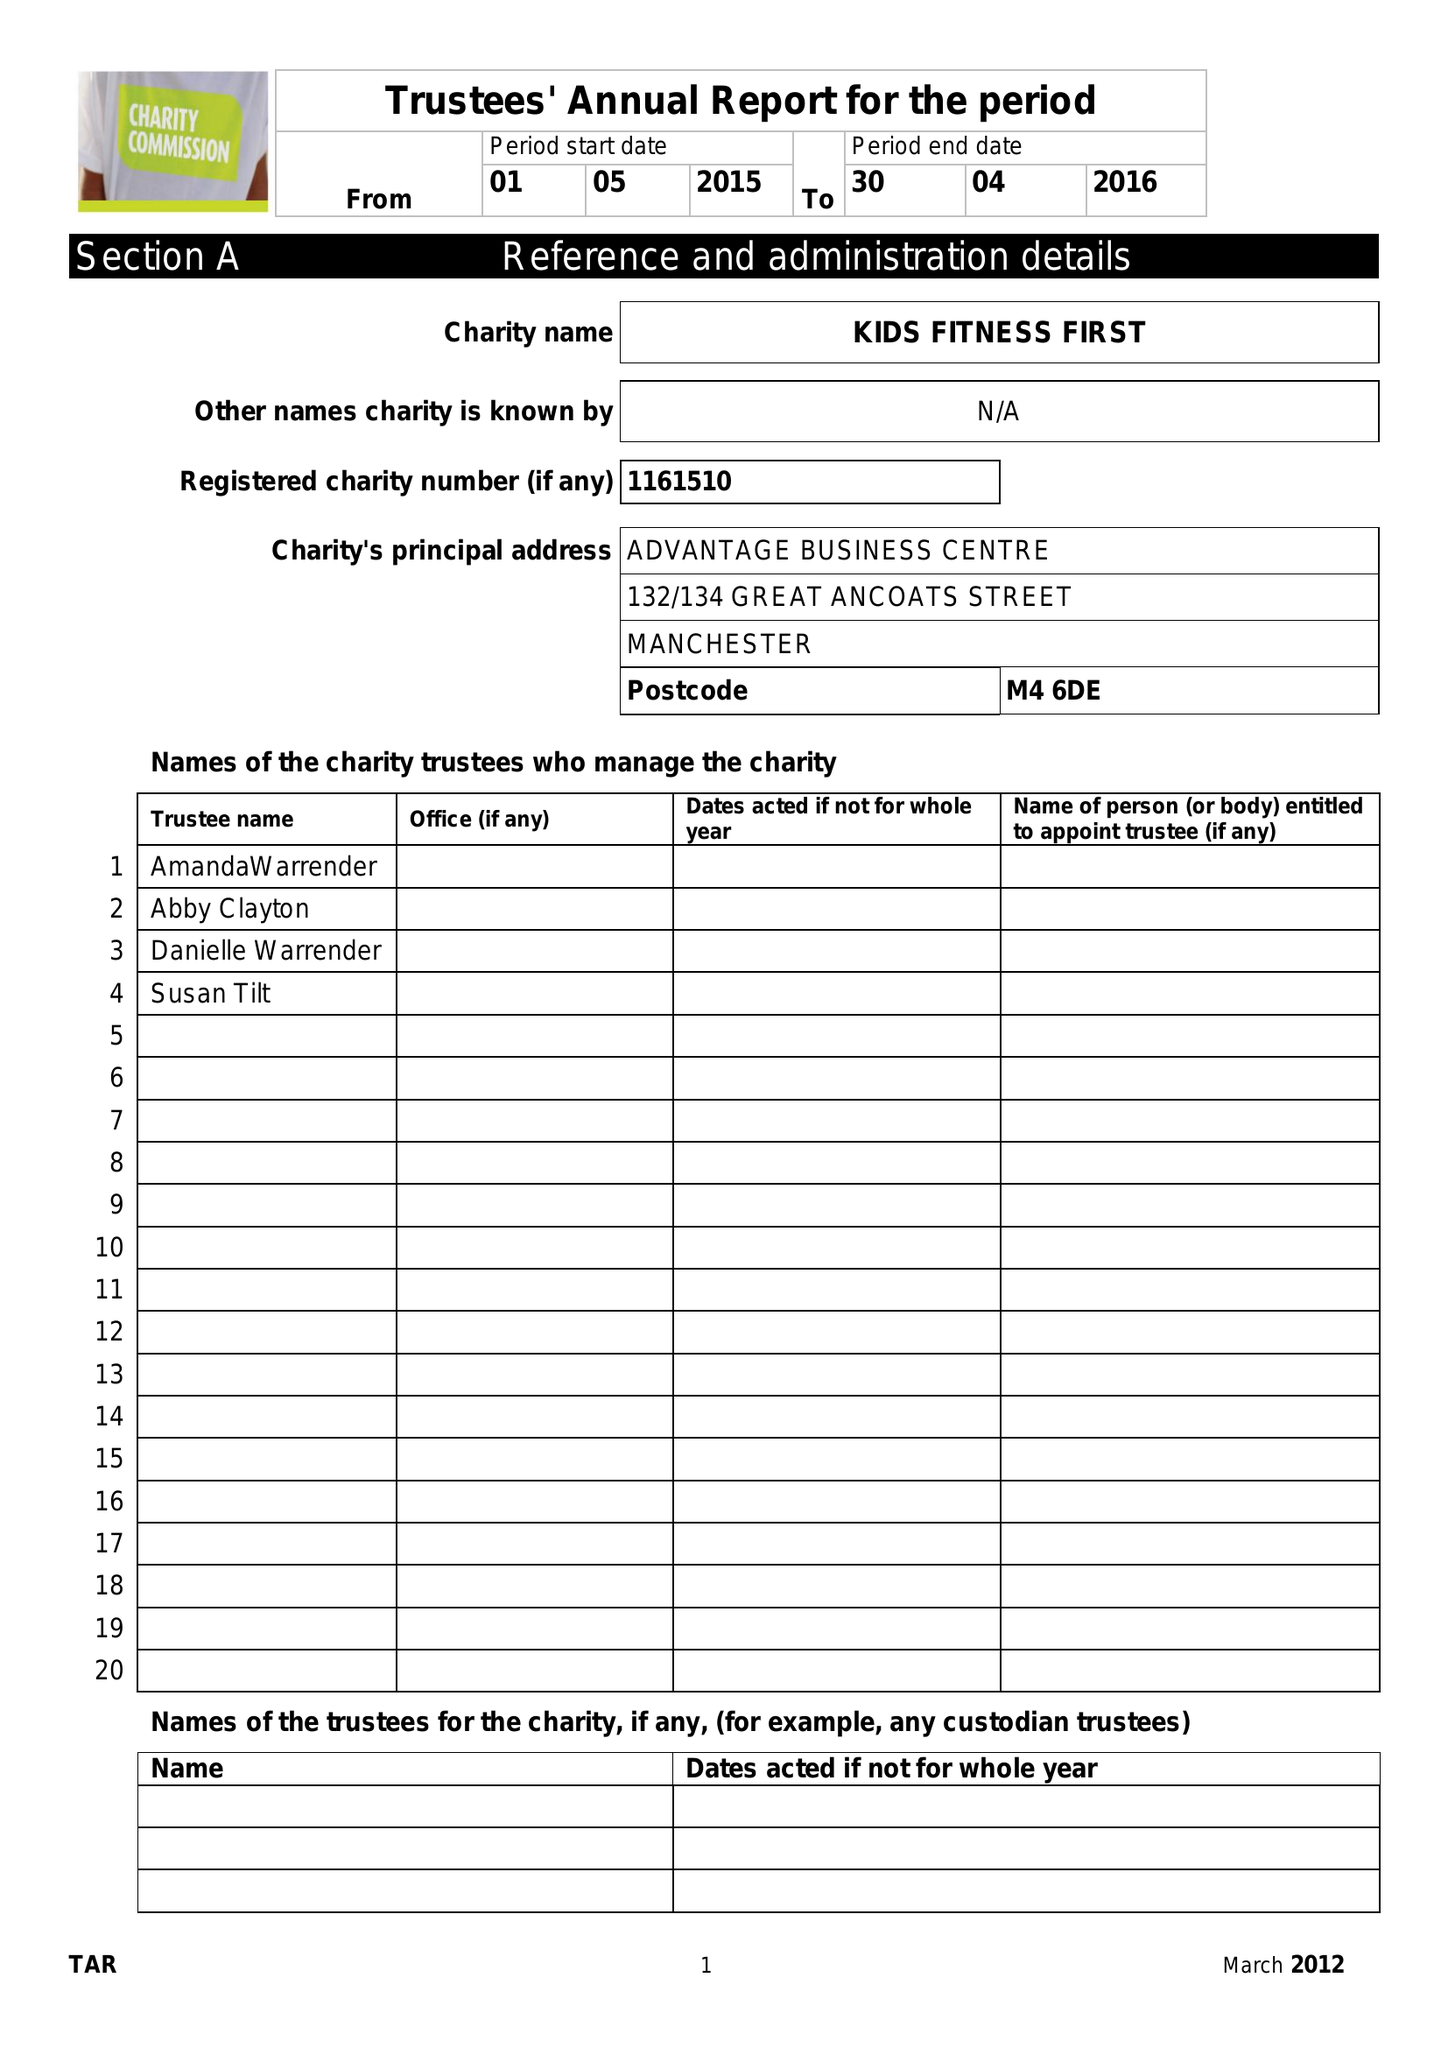What is the value for the income_annually_in_british_pounds?
Answer the question using a single word or phrase. None 